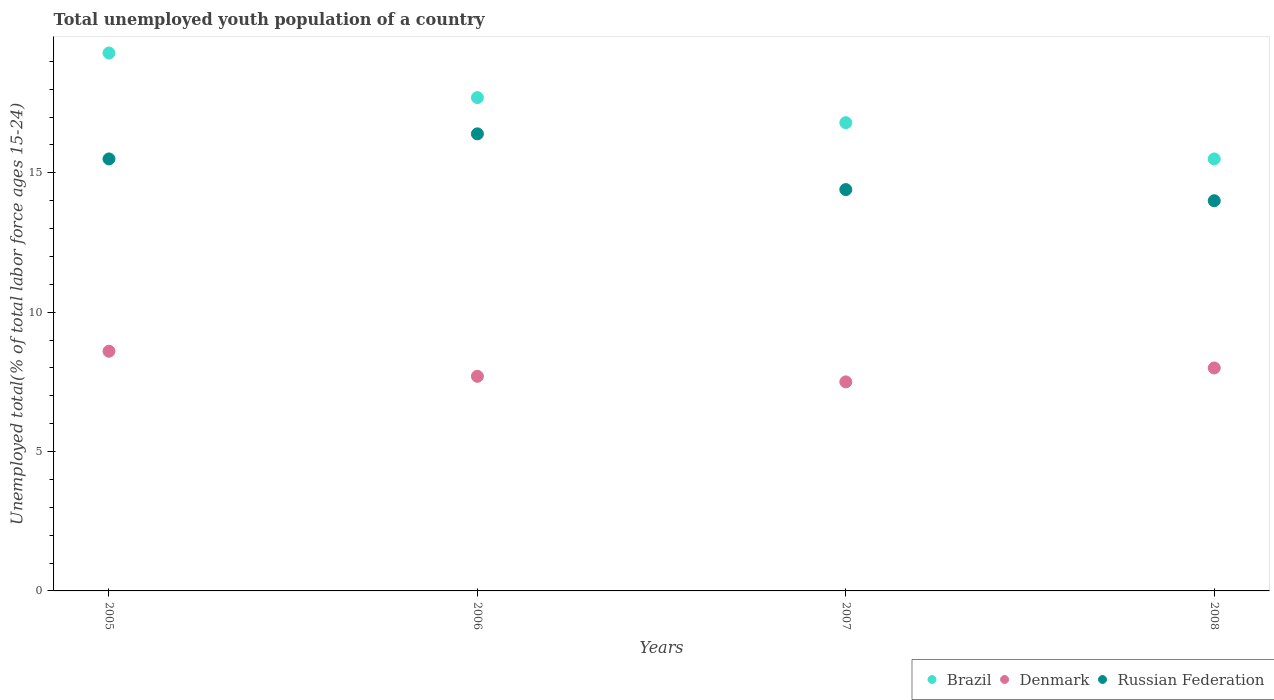How many different coloured dotlines are there?
Provide a succinct answer. 3. What is the percentage of total unemployed youth population of a country in Brazil in 2005?
Provide a short and direct response. 19.3. Across all years, what is the maximum percentage of total unemployed youth population of a country in Russian Federation?
Offer a very short reply. 16.4. In which year was the percentage of total unemployed youth population of a country in Russian Federation minimum?
Provide a succinct answer. 2008. What is the total percentage of total unemployed youth population of a country in Brazil in the graph?
Your answer should be very brief. 69.3. What is the difference between the percentage of total unemployed youth population of a country in Brazil in 2006 and that in 2008?
Your response must be concise. 2.2. What is the difference between the percentage of total unemployed youth population of a country in Brazil in 2006 and the percentage of total unemployed youth population of a country in Denmark in 2008?
Your answer should be compact. 9.7. What is the average percentage of total unemployed youth population of a country in Russian Federation per year?
Offer a terse response. 15.07. In the year 2008, what is the difference between the percentage of total unemployed youth population of a country in Denmark and percentage of total unemployed youth population of a country in Russian Federation?
Provide a short and direct response. -6. In how many years, is the percentage of total unemployed youth population of a country in Russian Federation greater than 6 %?
Make the answer very short. 4. What is the ratio of the percentage of total unemployed youth population of a country in Russian Federation in 2006 to that in 2007?
Offer a very short reply. 1.14. What is the difference between the highest and the second highest percentage of total unemployed youth population of a country in Denmark?
Make the answer very short. 0.6. What is the difference between the highest and the lowest percentage of total unemployed youth population of a country in Denmark?
Provide a short and direct response. 1.1. In how many years, is the percentage of total unemployed youth population of a country in Denmark greater than the average percentage of total unemployed youth population of a country in Denmark taken over all years?
Make the answer very short. 2. Is the sum of the percentage of total unemployed youth population of a country in Denmark in 2005 and 2007 greater than the maximum percentage of total unemployed youth population of a country in Brazil across all years?
Give a very brief answer. No. Is it the case that in every year, the sum of the percentage of total unemployed youth population of a country in Russian Federation and percentage of total unemployed youth population of a country in Brazil  is greater than the percentage of total unemployed youth population of a country in Denmark?
Offer a terse response. Yes. Is the percentage of total unemployed youth population of a country in Russian Federation strictly greater than the percentage of total unemployed youth population of a country in Denmark over the years?
Your answer should be very brief. Yes. How many years are there in the graph?
Your response must be concise. 4. What is the difference between two consecutive major ticks on the Y-axis?
Make the answer very short. 5. Are the values on the major ticks of Y-axis written in scientific E-notation?
Your answer should be very brief. No. Does the graph contain grids?
Your response must be concise. No. Where does the legend appear in the graph?
Ensure brevity in your answer.  Bottom right. How many legend labels are there?
Your answer should be compact. 3. What is the title of the graph?
Make the answer very short. Total unemployed youth population of a country. What is the label or title of the Y-axis?
Keep it short and to the point. Unemployed total(% of total labor force ages 15-24). What is the Unemployed total(% of total labor force ages 15-24) in Brazil in 2005?
Ensure brevity in your answer.  19.3. What is the Unemployed total(% of total labor force ages 15-24) in Denmark in 2005?
Provide a short and direct response. 8.6. What is the Unemployed total(% of total labor force ages 15-24) in Brazil in 2006?
Your answer should be compact. 17.7. What is the Unemployed total(% of total labor force ages 15-24) in Denmark in 2006?
Offer a terse response. 7.7. What is the Unemployed total(% of total labor force ages 15-24) of Russian Federation in 2006?
Offer a very short reply. 16.4. What is the Unemployed total(% of total labor force ages 15-24) of Brazil in 2007?
Make the answer very short. 16.8. What is the Unemployed total(% of total labor force ages 15-24) of Russian Federation in 2007?
Make the answer very short. 14.4. What is the Unemployed total(% of total labor force ages 15-24) in Brazil in 2008?
Your response must be concise. 15.5. What is the Unemployed total(% of total labor force ages 15-24) in Denmark in 2008?
Your response must be concise. 8. Across all years, what is the maximum Unemployed total(% of total labor force ages 15-24) in Brazil?
Provide a succinct answer. 19.3. Across all years, what is the maximum Unemployed total(% of total labor force ages 15-24) of Denmark?
Make the answer very short. 8.6. Across all years, what is the maximum Unemployed total(% of total labor force ages 15-24) of Russian Federation?
Ensure brevity in your answer.  16.4. Across all years, what is the minimum Unemployed total(% of total labor force ages 15-24) of Russian Federation?
Provide a succinct answer. 14. What is the total Unemployed total(% of total labor force ages 15-24) in Brazil in the graph?
Your answer should be very brief. 69.3. What is the total Unemployed total(% of total labor force ages 15-24) of Denmark in the graph?
Provide a succinct answer. 31.8. What is the total Unemployed total(% of total labor force ages 15-24) in Russian Federation in the graph?
Offer a terse response. 60.3. What is the difference between the Unemployed total(% of total labor force ages 15-24) of Russian Federation in 2005 and that in 2006?
Your answer should be very brief. -0.9. What is the difference between the Unemployed total(% of total labor force ages 15-24) of Brazil in 2005 and that in 2007?
Ensure brevity in your answer.  2.5. What is the difference between the Unemployed total(% of total labor force ages 15-24) in Denmark in 2005 and that in 2007?
Offer a very short reply. 1.1. What is the difference between the Unemployed total(% of total labor force ages 15-24) in Russian Federation in 2005 and that in 2007?
Your answer should be very brief. 1.1. What is the difference between the Unemployed total(% of total labor force ages 15-24) of Brazil in 2005 and that in 2008?
Provide a short and direct response. 3.8. What is the difference between the Unemployed total(% of total labor force ages 15-24) in Russian Federation in 2005 and that in 2008?
Offer a terse response. 1.5. What is the difference between the Unemployed total(% of total labor force ages 15-24) in Brazil in 2006 and that in 2007?
Your response must be concise. 0.9. What is the difference between the Unemployed total(% of total labor force ages 15-24) in Denmark in 2006 and that in 2007?
Offer a very short reply. 0.2. What is the difference between the Unemployed total(% of total labor force ages 15-24) of Russian Federation in 2006 and that in 2007?
Offer a very short reply. 2. What is the difference between the Unemployed total(% of total labor force ages 15-24) in Russian Federation in 2006 and that in 2008?
Ensure brevity in your answer.  2.4. What is the difference between the Unemployed total(% of total labor force ages 15-24) of Brazil in 2007 and that in 2008?
Provide a short and direct response. 1.3. What is the difference between the Unemployed total(% of total labor force ages 15-24) of Denmark in 2007 and that in 2008?
Keep it short and to the point. -0.5. What is the difference between the Unemployed total(% of total labor force ages 15-24) of Brazil in 2005 and the Unemployed total(% of total labor force ages 15-24) of Denmark in 2006?
Your answer should be very brief. 11.6. What is the difference between the Unemployed total(% of total labor force ages 15-24) of Brazil in 2005 and the Unemployed total(% of total labor force ages 15-24) of Russian Federation in 2006?
Your answer should be very brief. 2.9. What is the difference between the Unemployed total(% of total labor force ages 15-24) of Denmark in 2005 and the Unemployed total(% of total labor force ages 15-24) of Russian Federation in 2006?
Your answer should be compact. -7.8. What is the difference between the Unemployed total(% of total labor force ages 15-24) of Brazil in 2005 and the Unemployed total(% of total labor force ages 15-24) of Denmark in 2007?
Make the answer very short. 11.8. What is the difference between the Unemployed total(% of total labor force ages 15-24) of Brazil in 2005 and the Unemployed total(% of total labor force ages 15-24) of Russian Federation in 2008?
Provide a short and direct response. 5.3. What is the difference between the Unemployed total(% of total labor force ages 15-24) of Brazil in 2006 and the Unemployed total(% of total labor force ages 15-24) of Denmark in 2007?
Give a very brief answer. 10.2. What is the difference between the Unemployed total(% of total labor force ages 15-24) of Brazil in 2006 and the Unemployed total(% of total labor force ages 15-24) of Denmark in 2008?
Keep it short and to the point. 9.7. What is the difference between the Unemployed total(% of total labor force ages 15-24) in Brazil in 2006 and the Unemployed total(% of total labor force ages 15-24) in Russian Federation in 2008?
Offer a terse response. 3.7. What is the difference between the Unemployed total(% of total labor force ages 15-24) of Denmark in 2006 and the Unemployed total(% of total labor force ages 15-24) of Russian Federation in 2008?
Offer a terse response. -6.3. What is the average Unemployed total(% of total labor force ages 15-24) in Brazil per year?
Ensure brevity in your answer.  17.32. What is the average Unemployed total(% of total labor force ages 15-24) in Denmark per year?
Offer a very short reply. 7.95. What is the average Unemployed total(% of total labor force ages 15-24) of Russian Federation per year?
Offer a terse response. 15.07. In the year 2005, what is the difference between the Unemployed total(% of total labor force ages 15-24) of Brazil and Unemployed total(% of total labor force ages 15-24) of Denmark?
Your response must be concise. 10.7. In the year 2005, what is the difference between the Unemployed total(% of total labor force ages 15-24) of Denmark and Unemployed total(% of total labor force ages 15-24) of Russian Federation?
Keep it short and to the point. -6.9. In the year 2006, what is the difference between the Unemployed total(% of total labor force ages 15-24) in Brazil and Unemployed total(% of total labor force ages 15-24) in Denmark?
Your answer should be very brief. 10. In the year 2006, what is the difference between the Unemployed total(% of total labor force ages 15-24) of Brazil and Unemployed total(% of total labor force ages 15-24) of Russian Federation?
Your answer should be very brief. 1.3. In the year 2007, what is the difference between the Unemployed total(% of total labor force ages 15-24) in Brazil and Unemployed total(% of total labor force ages 15-24) in Russian Federation?
Keep it short and to the point. 2.4. In the year 2008, what is the difference between the Unemployed total(% of total labor force ages 15-24) in Brazil and Unemployed total(% of total labor force ages 15-24) in Denmark?
Offer a very short reply. 7.5. In the year 2008, what is the difference between the Unemployed total(% of total labor force ages 15-24) of Brazil and Unemployed total(% of total labor force ages 15-24) of Russian Federation?
Your response must be concise. 1.5. In the year 2008, what is the difference between the Unemployed total(% of total labor force ages 15-24) in Denmark and Unemployed total(% of total labor force ages 15-24) in Russian Federation?
Give a very brief answer. -6. What is the ratio of the Unemployed total(% of total labor force ages 15-24) in Brazil in 2005 to that in 2006?
Provide a succinct answer. 1.09. What is the ratio of the Unemployed total(% of total labor force ages 15-24) of Denmark in 2005 to that in 2006?
Your response must be concise. 1.12. What is the ratio of the Unemployed total(% of total labor force ages 15-24) of Russian Federation in 2005 to that in 2006?
Your answer should be compact. 0.95. What is the ratio of the Unemployed total(% of total labor force ages 15-24) of Brazil in 2005 to that in 2007?
Your response must be concise. 1.15. What is the ratio of the Unemployed total(% of total labor force ages 15-24) in Denmark in 2005 to that in 2007?
Keep it short and to the point. 1.15. What is the ratio of the Unemployed total(% of total labor force ages 15-24) in Russian Federation in 2005 to that in 2007?
Give a very brief answer. 1.08. What is the ratio of the Unemployed total(% of total labor force ages 15-24) of Brazil in 2005 to that in 2008?
Offer a very short reply. 1.25. What is the ratio of the Unemployed total(% of total labor force ages 15-24) of Denmark in 2005 to that in 2008?
Keep it short and to the point. 1.07. What is the ratio of the Unemployed total(% of total labor force ages 15-24) of Russian Federation in 2005 to that in 2008?
Provide a succinct answer. 1.11. What is the ratio of the Unemployed total(% of total labor force ages 15-24) in Brazil in 2006 to that in 2007?
Give a very brief answer. 1.05. What is the ratio of the Unemployed total(% of total labor force ages 15-24) in Denmark in 2006 to that in 2007?
Ensure brevity in your answer.  1.03. What is the ratio of the Unemployed total(% of total labor force ages 15-24) of Russian Federation in 2006 to that in 2007?
Offer a very short reply. 1.14. What is the ratio of the Unemployed total(% of total labor force ages 15-24) in Brazil in 2006 to that in 2008?
Your response must be concise. 1.14. What is the ratio of the Unemployed total(% of total labor force ages 15-24) in Denmark in 2006 to that in 2008?
Your answer should be compact. 0.96. What is the ratio of the Unemployed total(% of total labor force ages 15-24) in Russian Federation in 2006 to that in 2008?
Your response must be concise. 1.17. What is the ratio of the Unemployed total(% of total labor force ages 15-24) in Brazil in 2007 to that in 2008?
Your answer should be very brief. 1.08. What is the ratio of the Unemployed total(% of total labor force ages 15-24) of Denmark in 2007 to that in 2008?
Keep it short and to the point. 0.94. What is the ratio of the Unemployed total(% of total labor force ages 15-24) of Russian Federation in 2007 to that in 2008?
Give a very brief answer. 1.03. What is the difference between the highest and the second highest Unemployed total(% of total labor force ages 15-24) of Brazil?
Make the answer very short. 1.6. What is the difference between the highest and the second highest Unemployed total(% of total labor force ages 15-24) of Denmark?
Provide a succinct answer. 0.6. What is the difference between the highest and the second highest Unemployed total(% of total labor force ages 15-24) of Russian Federation?
Offer a terse response. 0.9. What is the difference between the highest and the lowest Unemployed total(% of total labor force ages 15-24) of Brazil?
Give a very brief answer. 3.8. What is the difference between the highest and the lowest Unemployed total(% of total labor force ages 15-24) in Denmark?
Make the answer very short. 1.1. 